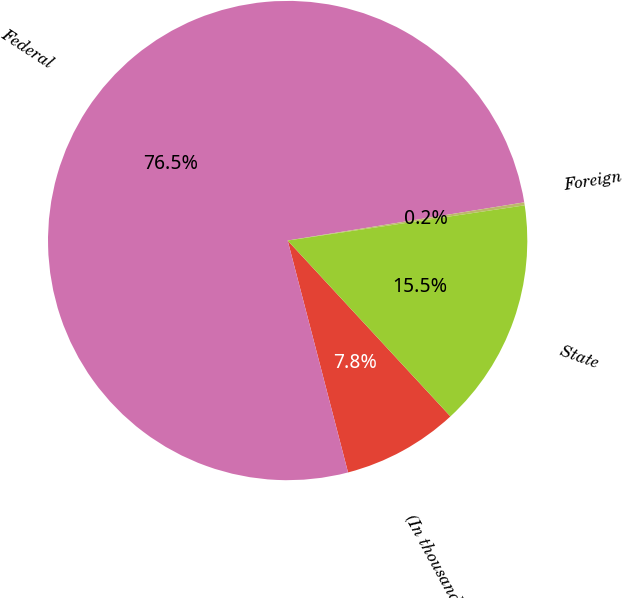<chart> <loc_0><loc_0><loc_500><loc_500><pie_chart><fcel>(In thousands)<fcel>Federal<fcel>Foreign<fcel>State<nl><fcel>7.83%<fcel>76.5%<fcel>0.2%<fcel>15.46%<nl></chart> 